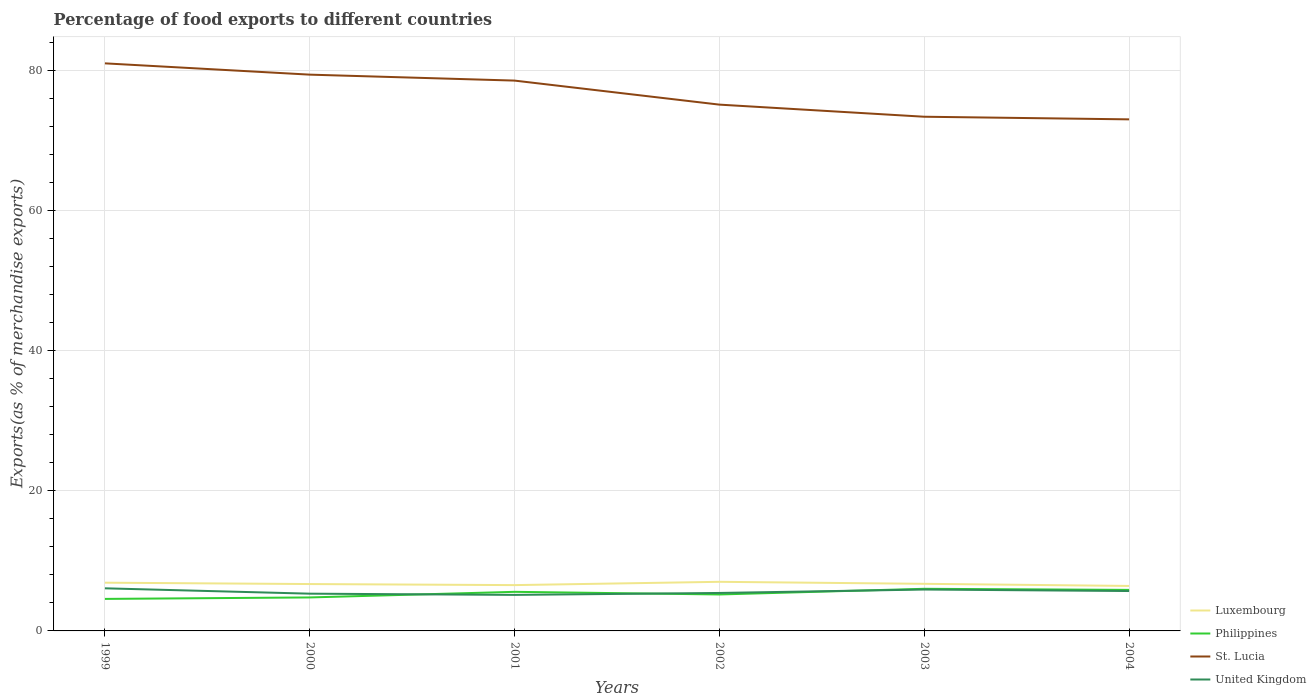How many different coloured lines are there?
Provide a short and direct response. 4. Is the number of lines equal to the number of legend labels?
Provide a succinct answer. Yes. Across all years, what is the maximum percentage of exports to different countries in Luxembourg?
Provide a short and direct response. 6.42. In which year was the percentage of exports to different countries in Luxembourg maximum?
Make the answer very short. 2004. What is the total percentage of exports to different countries in United Kingdom in the graph?
Offer a terse response. -0.38. What is the difference between the highest and the second highest percentage of exports to different countries in United Kingdom?
Offer a terse response. 0.94. What is the difference between the highest and the lowest percentage of exports to different countries in United Kingdom?
Provide a succinct answer. 3. Is the percentage of exports to different countries in United Kingdom strictly greater than the percentage of exports to different countries in Philippines over the years?
Your answer should be very brief. No. How many years are there in the graph?
Offer a very short reply. 6. Does the graph contain any zero values?
Provide a short and direct response. No. What is the title of the graph?
Offer a terse response. Percentage of food exports to different countries. Does "Cyprus" appear as one of the legend labels in the graph?
Make the answer very short. No. What is the label or title of the Y-axis?
Your answer should be very brief. Exports(as % of merchandise exports). What is the Exports(as % of merchandise exports) in Luxembourg in 1999?
Make the answer very short. 6.88. What is the Exports(as % of merchandise exports) of Philippines in 1999?
Offer a terse response. 4.57. What is the Exports(as % of merchandise exports) in St. Lucia in 1999?
Make the answer very short. 81.01. What is the Exports(as % of merchandise exports) of United Kingdom in 1999?
Ensure brevity in your answer.  6.08. What is the Exports(as % of merchandise exports) of Luxembourg in 2000?
Your answer should be compact. 6.69. What is the Exports(as % of merchandise exports) in Philippines in 2000?
Offer a very short reply. 4.78. What is the Exports(as % of merchandise exports) of St. Lucia in 2000?
Make the answer very short. 79.4. What is the Exports(as % of merchandise exports) of United Kingdom in 2000?
Keep it short and to the point. 5.32. What is the Exports(as % of merchandise exports) of Luxembourg in 2001?
Offer a terse response. 6.54. What is the Exports(as % of merchandise exports) of Philippines in 2001?
Your response must be concise. 5.58. What is the Exports(as % of merchandise exports) in St. Lucia in 2001?
Provide a succinct answer. 78.55. What is the Exports(as % of merchandise exports) in United Kingdom in 2001?
Make the answer very short. 5.14. What is the Exports(as % of merchandise exports) in Luxembourg in 2002?
Make the answer very short. 7.01. What is the Exports(as % of merchandise exports) in Philippines in 2002?
Offer a terse response. 5.2. What is the Exports(as % of merchandise exports) in St. Lucia in 2002?
Keep it short and to the point. 75.12. What is the Exports(as % of merchandise exports) in United Kingdom in 2002?
Offer a terse response. 5.42. What is the Exports(as % of merchandise exports) of Luxembourg in 2003?
Your response must be concise. 6.72. What is the Exports(as % of merchandise exports) in Philippines in 2003?
Your answer should be compact. 6.01. What is the Exports(as % of merchandise exports) of St. Lucia in 2003?
Ensure brevity in your answer.  73.39. What is the Exports(as % of merchandise exports) in United Kingdom in 2003?
Make the answer very short. 5.91. What is the Exports(as % of merchandise exports) in Luxembourg in 2004?
Give a very brief answer. 6.42. What is the Exports(as % of merchandise exports) in Philippines in 2004?
Your answer should be compact. 5.86. What is the Exports(as % of merchandise exports) of St. Lucia in 2004?
Provide a succinct answer. 73.02. What is the Exports(as % of merchandise exports) of United Kingdom in 2004?
Offer a very short reply. 5.69. Across all years, what is the maximum Exports(as % of merchandise exports) of Luxembourg?
Provide a short and direct response. 7.01. Across all years, what is the maximum Exports(as % of merchandise exports) in Philippines?
Provide a succinct answer. 6.01. Across all years, what is the maximum Exports(as % of merchandise exports) of St. Lucia?
Offer a very short reply. 81.01. Across all years, what is the maximum Exports(as % of merchandise exports) of United Kingdom?
Ensure brevity in your answer.  6.08. Across all years, what is the minimum Exports(as % of merchandise exports) of Luxembourg?
Make the answer very short. 6.42. Across all years, what is the minimum Exports(as % of merchandise exports) of Philippines?
Offer a very short reply. 4.57. Across all years, what is the minimum Exports(as % of merchandise exports) in St. Lucia?
Provide a short and direct response. 73.02. Across all years, what is the minimum Exports(as % of merchandise exports) of United Kingdom?
Your answer should be compact. 5.14. What is the total Exports(as % of merchandise exports) in Luxembourg in the graph?
Provide a short and direct response. 40.27. What is the total Exports(as % of merchandise exports) of Philippines in the graph?
Your answer should be very brief. 32. What is the total Exports(as % of merchandise exports) of St. Lucia in the graph?
Provide a short and direct response. 460.49. What is the total Exports(as % of merchandise exports) in United Kingdom in the graph?
Your answer should be very brief. 33.56. What is the difference between the Exports(as % of merchandise exports) of Luxembourg in 1999 and that in 2000?
Your answer should be compact. 0.2. What is the difference between the Exports(as % of merchandise exports) in Philippines in 1999 and that in 2000?
Your response must be concise. -0.21. What is the difference between the Exports(as % of merchandise exports) of St. Lucia in 1999 and that in 2000?
Make the answer very short. 1.61. What is the difference between the Exports(as % of merchandise exports) in United Kingdom in 1999 and that in 2000?
Provide a succinct answer. 0.77. What is the difference between the Exports(as % of merchandise exports) in Luxembourg in 1999 and that in 2001?
Offer a terse response. 0.35. What is the difference between the Exports(as % of merchandise exports) in Philippines in 1999 and that in 2001?
Provide a succinct answer. -1.01. What is the difference between the Exports(as % of merchandise exports) of St. Lucia in 1999 and that in 2001?
Your response must be concise. 2.46. What is the difference between the Exports(as % of merchandise exports) of United Kingdom in 1999 and that in 2001?
Offer a terse response. 0.94. What is the difference between the Exports(as % of merchandise exports) of Luxembourg in 1999 and that in 2002?
Your answer should be very brief. -0.12. What is the difference between the Exports(as % of merchandise exports) in Philippines in 1999 and that in 2002?
Provide a succinct answer. -0.63. What is the difference between the Exports(as % of merchandise exports) of St. Lucia in 1999 and that in 2002?
Offer a terse response. 5.89. What is the difference between the Exports(as % of merchandise exports) of United Kingdom in 1999 and that in 2002?
Provide a short and direct response. 0.66. What is the difference between the Exports(as % of merchandise exports) in Luxembourg in 1999 and that in 2003?
Offer a very short reply. 0.16. What is the difference between the Exports(as % of merchandise exports) of Philippines in 1999 and that in 2003?
Your answer should be very brief. -1.44. What is the difference between the Exports(as % of merchandise exports) in St. Lucia in 1999 and that in 2003?
Keep it short and to the point. 7.62. What is the difference between the Exports(as % of merchandise exports) in United Kingdom in 1999 and that in 2003?
Give a very brief answer. 0.17. What is the difference between the Exports(as % of merchandise exports) in Luxembourg in 1999 and that in 2004?
Your answer should be compact. 0.46. What is the difference between the Exports(as % of merchandise exports) of Philippines in 1999 and that in 2004?
Ensure brevity in your answer.  -1.29. What is the difference between the Exports(as % of merchandise exports) of St. Lucia in 1999 and that in 2004?
Your answer should be compact. 7.99. What is the difference between the Exports(as % of merchandise exports) in United Kingdom in 1999 and that in 2004?
Offer a terse response. 0.39. What is the difference between the Exports(as % of merchandise exports) of Luxembourg in 2000 and that in 2001?
Your answer should be compact. 0.15. What is the difference between the Exports(as % of merchandise exports) in Philippines in 2000 and that in 2001?
Give a very brief answer. -0.8. What is the difference between the Exports(as % of merchandise exports) of St. Lucia in 2000 and that in 2001?
Offer a terse response. 0.85. What is the difference between the Exports(as % of merchandise exports) of United Kingdom in 2000 and that in 2001?
Provide a succinct answer. 0.17. What is the difference between the Exports(as % of merchandise exports) of Luxembourg in 2000 and that in 2002?
Offer a very short reply. -0.32. What is the difference between the Exports(as % of merchandise exports) in Philippines in 2000 and that in 2002?
Keep it short and to the point. -0.42. What is the difference between the Exports(as % of merchandise exports) of St. Lucia in 2000 and that in 2002?
Keep it short and to the point. 4.28. What is the difference between the Exports(as % of merchandise exports) in United Kingdom in 2000 and that in 2002?
Provide a succinct answer. -0.1. What is the difference between the Exports(as % of merchandise exports) in Luxembourg in 2000 and that in 2003?
Make the answer very short. -0.04. What is the difference between the Exports(as % of merchandise exports) in Philippines in 2000 and that in 2003?
Your answer should be very brief. -1.23. What is the difference between the Exports(as % of merchandise exports) of St. Lucia in 2000 and that in 2003?
Your answer should be very brief. 6.01. What is the difference between the Exports(as % of merchandise exports) of United Kingdom in 2000 and that in 2003?
Provide a short and direct response. -0.59. What is the difference between the Exports(as % of merchandise exports) in Luxembourg in 2000 and that in 2004?
Give a very brief answer. 0.27. What is the difference between the Exports(as % of merchandise exports) in Philippines in 2000 and that in 2004?
Give a very brief answer. -1.08. What is the difference between the Exports(as % of merchandise exports) in St. Lucia in 2000 and that in 2004?
Ensure brevity in your answer.  6.38. What is the difference between the Exports(as % of merchandise exports) of United Kingdom in 2000 and that in 2004?
Provide a succinct answer. -0.38. What is the difference between the Exports(as % of merchandise exports) of Luxembourg in 2001 and that in 2002?
Provide a short and direct response. -0.47. What is the difference between the Exports(as % of merchandise exports) in Philippines in 2001 and that in 2002?
Offer a very short reply. 0.38. What is the difference between the Exports(as % of merchandise exports) of St. Lucia in 2001 and that in 2002?
Ensure brevity in your answer.  3.43. What is the difference between the Exports(as % of merchandise exports) in United Kingdom in 2001 and that in 2002?
Provide a short and direct response. -0.28. What is the difference between the Exports(as % of merchandise exports) of Luxembourg in 2001 and that in 2003?
Offer a very short reply. -0.19. What is the difference between the Exports(as % of merchandise exports) of Philippines in 2001 and that in 2003?
Your response must be concise. -0.43. What is the difference between the Exports(as % of merchandise exports) of St. Lucia in 2001 and that in 2003?
Offer a very short reply. 5.16. What is the difference between the Exports(as % of merchandise exports) in United Kingdom in 2001 and that in 2003?
Your response must be concise. -0.77. What is the difference between the Exports(as % of merchandise exports) of Luxembourg in 2001 and that in 2004?
Give a very brief answer. 0.12. What is the difference between the Exports(as % of merchandise exports) in Philippines in 2001 and that in 2004?
Your response must be concise. -0.28. What is the difference between the Exports(as % of merchandise exports) in St. Lucia in 2001 and that in 2004?
Offer a terse response. 5.53. What is the difference between the Exports(as % of merchandise exports) in United Kingdom in 2001 and that in 2004?
Your answer should be compact. -0.55. What is the difference between the Exports(as % of merchandise exports) of Luxembourg in 2002 and that in 2003?
Your answer should be very brief. 0.28. What is the difference between the Exports(as % of merchandise exports) of Philippines in 2002 and that in 2003?
Make the answer very short. -0.81. What is the difference between the Exports(as % of merchandise exports) of St. Lucia in 2002 and that in 2003?
Keep it short and to the point. 1.73. What is the difference between the Exports(as % of merchandise exports) of United Kingdom in 2002 and that in 2003?
Give a very brief answer. -0.49. What is the difference between the Exports(as % of merchandise exports) in Luxembourg in 2002 and that in 2004?
Give a very brief answer. 0.59. What is the difference between the Exports(as % of merchandise exports) in Philippines in 2002 and that in 2004?
Give a very brief answer. -0.65. What is the difference between the Exports(as % of merchandise exports) of St. Lucia in 2002 and that in 2004?
Offer a very short reply. 2.1. What is the difference between the Exports(as % of merchandise exports) in United Kingdom in 2002 and that in 2004?
Offer a terse response. -0.27. What is the difference between the Exports(as % of merchandise exports) in Luxembourg in 2003 and that in 2004?
Ensure brevity in your answer.  0.3. What is the difference between the Exports(as % of merchandise exports) in Philippines in 2003 and that in 2004?
Your answer should be compact. 0.16. What is the difference between the Exports(as % of merchandise exports) of St. Lucia in 2003 and that in 2004?
Provide a short and direct response. 0.37. What is the difference between the Exports(as % of merchandise exports) of United Kingdom in 2003 and that in 2004?
Make the answer very short. 0.21. What is the difference between the Exports(as % of merchandise exports) of Luxembourg in 1999 and the Exports(as % of merchandise exports) of Philippines in 2000?
Provide a succinct answer. 2.11. What is the difference between the Exports(as % of merchandise exports) in Luxembourg in 1999 and the Exports(as % of merchandise exports) in St. Lucia in 2000?
Provide a succinct answer. -72.51. What is the difference between the Exports(as % of merchandise exports) of Luxembourg in 1999 and the Exports(as % of merchandise exports) of United Kingdom in 2000?
Give a very brief answer. 1.57. What is the difference between the Exports(as % of merchandise exports) in Philippines in 1999 and the Exports(as % of merchandise exports) in St. Lucia in 2000?
Provide a succinct answer. -74.83. What is the difference between the Exports(as % of merchandise exports) of Philippines in 1999 and the Exports(as % of merchandise exports) of United Kingdom in 2000?
Your answer should be very brief. -0.75. What is the difference between the Exports(as % of merchandise exports) in St. Lucia in 1999 and the Exports(as % of merchandise exports) in United Kingdom in 2000?
Keep it short and to the point. 75.69. What is the difference between the Exports(as % of merchandise exports) of Luxembourg in 1999 and the Exports(as % of merchandise exports) of Philippines in 2001?
Your response must be concise. 1.31. What is the difference between the Exports(as % of merchandise exports) in Luxembourg in 1999 and the Exports(as % of merchandise exports) in St. Lucia in 2001?
Your answer should be very brief. -71.67. What is the difference between the Exports(as % of merchandise exports) in Luxembourg in 1999 and the Exports(as % of merchandise exports) in United Kingdom in 2001?
Provide a succinct answer. 1.74. What is the difference between the Exports(as % of merchandise exports) in Philippines in 1999 and the Exports(as % of merchandise exports) in St. Lucia in 2001?
Keep it short and to the point. -73.98. What is the difference between the Exports(as % of merchandise exports) in Philippines in 1999 and the Exports(as % of merchandise exports) in United Kingdom in 2001?
Your answer should be compact. -0.57. What is the difference between the Exports(as % of merchandise exports) in St. Lucia in 1999 and the Exports(as % of merchandise exports) in United Kingdom in 2001?
Provide a short and direct response. 75.87. What is the difference between the Exports(as % of merchandise exports) of Luxembourg in 1999 and the Exports(as % of merchandise exports) of Philippines in 2002?
Offer a terse response. 1.68. What is the difference between the Exports(as % of merchandise exports) of Luxembourg in 1999 and the Exports(as % of merchandise exports) of St. Lucia in 2002?
Offer a terse response. -68.24. What is the difference between the Exports(as % of merchandise exports) in Luxembourg in 1999 and the Exports(as % of merchandise exports) in United Kingdom in 2002?
Your answer should be compact. 1.47. What is the difference between the Exports(as % of merchandise exports) of Philippines in 1999 and the Exports(as % of merchandise exports) of St. Lucia in 2002?
Your answer should be compact. -70.55. What is the difference between the Exports(as % of merchandise exports) of Philippines in 1999 and the Exports(as % of merchandise exports) of United Kingdom in 2002?
Your answer should be very brief. -0.85. What is the difference between the Exports(as % of merchandise exports) in St. Lucia in 1999 and the Exports(as % of merchandise exports) in United Kingdom in 2002?
Provide a short and direct response. 75.59. What is the difference between the Exports(as % of merchandise exports) of Luxembourg in 1999 and the Exports(as % of merchandise exports) of Philippines in 2003?
Keep it short and to the point. 0.87. What is the difference between the Exports(as % of merchandise exports) of Luxembourg in 1999 and the Exports(as % of merchandise exports) of St. Lucia in 2003?
Your answer should be compact. -66.51. What is the difference between the Exports(as % of merchandise exports) in Luxembourg in 1999 and the Exports(as % of merchandise exports) in United Kingdom in 2003?
Your answer should be very brief. 0.98. What is the difference between the Exports(as % of merchandise exports) in Philippines in 1999 and the Exports(as % of merchandise exports) in St. Lucia in 2003?
Provide a short and direct response. -68.82. What is the difference between the Exports(as % of merchandise exports) of Philippines in 1999 and the Exports(as % of merchandise exports) of United Kingdom in 2003?
Give a very brief answer. -1.34. What is the difference between the Exports(as % of merchandise exports) in St. Lucia in 1999 and the Exports(as % of merchandise exports) in United Kingdom in 2003?
Make the answer very short. 75.1. What is the difference between the Exports(as % of merchandise exports) of Luxembourg in 1999 and the Exports(as % of merchandise exports) of Philippines in 2004?
Make the answer very short. 1.03. What is the difference between the Exports(as % of merchandise exports) in Luxembourg in 1999 and the Exports(as % of merchandise exports) in St. Lucia in 2004?
Your response must be concise. -66.13. What is the difference between the Exports(as % of merchandise exports) in Luxembourg in 1999 and the Exports(as % of merchandise exports) in United Kingdom in 2004?
Your response must be concise. 1.19. What is the difference between the Exports(as % of merchandise exports) in Philippines in 1999 and the Exports(as % of merchandise exports) in St. Lucia in 2004?
Give a very brief answer. -68.45. What is the difference between the Exports(as % of merchandise exports) in Philippines in 1999 and the Exports(as % of merchandise exports) in United Kingdom in 2004?
Keep it short and to the point. -1.12. What is the difference between the Exports(as % of merchandise exports) in St. Lucia in 1999 and the Exports(as % of merchandise exports) in United Kingdom in 2004?
Your answer should be very brief. 75.32. What is the difference between the Exports(as % of merchandise exports) of Luxembourg in 2000 and the Exports(as % of merchandise exports) of Philippines in 2001?
Give a very brief answer. 1.11. What is the difference between the Exports(as % of merchandise exports) of Luxembourg in 2000 and the Exports(as % of merchandise exports) of St. Lucia in 2001?
Give a very brief answer. -71.86. What is the difference between the Exports(as % of merchandise exports) of Luxembourg in 2000 and the Exports(as % of merchandise exports) of United Kingdom in 2001?
Your answer should be very brief. 1.55. What is the difference between the Exports(as % of merchandise exports) of Philippines in 2000 and the Exports(as % of merchandise exports) of St. Lucia in 2001?
Your answer should be compact. -73.77. What is the difference between the Exports(as % of merchandise exports) of Philippines in 2000 and the Exports(as % of merchandise exports) of United Kingdom in 2001?
Offer a terse response. -0.36. What is the difference between the Exports(as % of merchandise exports) of St. Lucia in 2000 and the Exports(as % of merchandise exports) of United Kingdom in 2001?
Your answer should be very brief. 74.26. What is the difference between the Exports(as % of merchandise exports) in Luxembourg in 2000 and the Exports(as % of merchandise exports) in Philippines in 2002?
Give a very brief answer. 1.49. What is the difference between the Exports(as % of merchandise exports) in Luxembourg in 2000 and the Exports(as % of merchandise exports) in St. Lucia in 2002?
Keep it short and to the point. -68.43. What is the difference between the Exports(as % of merchandise exports) of Luxembourg in 2000 and the Exports(as % of merchandise exports) of United Kingdom in 2002?
Give a very brief answer. 1.27. What is the difference between the Exports(as % of merchandise exports) in Philippines in 2000 and the Exports(as % of merchandise exports) in St. Lucia in 2002?
Ensure brevity in your answer.  -70.34. What is the difference between the Exports(as % of merchandise exports) of Philippines in 2000 and the Exports(as % of merchandise exports) of United Kingdom in 2002?
Your answer should be very brief. -0.64. What is the difference between the Exports(as % of merchandise exports) in St. Lucia in 2000 and the Exports(as % of merchandise exports) in United Kingdom in 2002?
Your answer should be very brief. 73.98. What is the difference between the Exports(as % of merchandise exports) in Luxembourg in 2000 and the Exports(as % of merchandise exports) in Philippines in 2003?
Your answer should be very brief. 0.68. What is the difference between the Exports(as % of merchandise exports) of Luxembourg in 2000 and the Exports(as % of merchandise exports) of St. Lucia in 2003?
Provide a short and direct response. -66.7. What is the difference between the Exports(as % of merchandise exports) of Luxembourg in 2000 and the Exports(as % of merchandise exports) of United Kingdom in 2003?
Ensure brevity in your answer.  0.78. What is the difference between the Exports(as % of merchandise exports) in Philippines in 2000 and the Exports(as % of merchandise exports) in St. Lucia in 2003?
Your answer should be compact. -68.61. What is the difference between the Exports(as % of merchandise exports) of Philippines in 2000 and the Exports(as % of merchandise exports) of United Kingdom in 2003?
Your response must be concise. -1.13. What is the difference between the Exports(as % of merchandise exports) in St. Lucia in 2000 and the Exports(as % of merchandise exports) in United Kingdom in 2003?
Your response must be concise. 73.49. What is the difference between the Exports(as % of merchandise exports) in Luxembourg in 2000 and the Exports(as % of merchandise exports) in Philippines in 2004?
Offer a terse response. 0.83. What is the difference between the Exports(as % of merchandise exports) of Luxembourg in 2000 and the Exports(as % of merchandise exports) of St. Lucia in 2004?
Ensure brevity in your answer.  -66.33. What is the difference between the Exports(as % of merchandise exports) of Philippines in 2000 and the Exports(as % of merchandise exports) of St. Lucia in 2004?
Your answer should be compact. -68.24. What is the difference between the Exports(as % of merchandise exports) of Philippines in 2000 and the Exports(as % of merchandise exports) of United Kingdom in 2004?
Your answer should be compact. -0.91. What is the difference between the Exports(as % of merchandise exports) of St. Lucia in 2000 and the Exports(as % of merchandise exports) of United Kingdom in 2004?
Keep it short and to the point. 73.71. What is the difference between the Exports(as % of merchandise exports) in Luxembourg in 2001 and the Exports(as % of merchandise exports) in Philippines in 2002?
Your response must be concise. 1.34. What is the difference between the Exports(as % of merchandise exports) of Luxembourg in 2001 and the Exports(as % of merchandise exports) of St. Lucia in 2002?
Your answer should be compact. -68.58. What is the difference between the Exports(as % of merchandise exports) of Luxembourg in 2001 and the Exports(as % of merchandise exports) of United Kingdom in 2002?
Offer a terse response. 1.12. What is the difference between the Exports(as % of merchandise exports) in Philippines in 2001 and the Exports(as % of merchandise exports) in St. Lucia in 2002?
Your answer should be very brief. -69.54. What is the difference between the Exports(as % of merchandise exports) of Philippines in 2001 and the Exports(as % of merchandise exports) of United Kingdom in 2002?
Make the answer very short. 0.16. What is the difference between the Exports(as % of merchandise exports) of St. Lucia in 2001 and the Exports(as % of merchandise exports) of United Kingdom in 2002?
Provide a short and direct response. 73.13. What is the difference between the Exports(as % of merchandise exports) of Luxembourg in 2001 and the Exports(as % of merchandise exports) of Philippines in 2003?
Your response must be concise. 0.53. What is the difference between the Exports(as % of merchandise exports) of Luxembourg in 2001 and the Exports(as % of merchandise exports) of St. Lucia in 2003?
Ensure brevity in your answer.  -66.85. What is the difference between the Exports(as % of merchandise exports) of Luxembourg in 2001 and the Exports(as % of merchandise exports) of United Kingdom in 2003?
Provide a short and direct response. 0.63. What is the difference between the Exports(as % of merchandise exports) in Philippines in 2001 and the Exports(as % of merchandise exports) in St. Lucia in 2003?
Provide a succinct answer. -67.81. What is the difference between the Exports(as % of merchandise exports) of Philippines in 2001 and the Exports(as % of merchandise exports) of United Kingdom in 2003?
Your answer should be compact. -0.33. What is the difference between the Exports(as % of merchandise exports) of St. Lucia in 2001 and the Exports(as % of merchandise exports) of United Kingdom in 2003?
Your answer should be very brief. 72.64. What is the difference between the Exports(as % of merchandise exports) of Luxembourg in 2001 and the Exports(as % of merchandise exports) of Philippines in 2004?
Keep it short and to the point. 0.68. What is the difference between the Exports(as % of merchandise exports) of Luxembourg in 2001 and the Exports(as % of merchandise exports) of St. Lucia in 2004?
Your response must be concise. -66.48. What is the difference between the Exports(as % of merchandise exports) in Luxembourg in 2001 and the Exports(as % of merchandise exports) in United Kingdom in 2004?
Ensure brevity in your answer.  0.85. What is the difference between the Exports(as % of merchandise exports) of Philippines in 2001 and the Exports(as % of merchandise exports) of St. Lucia in 2004?
Ensure brevity in your answer.  -67.44. What is the difference between the Exports(as % of merchandise exports) in Philippines in 2001 and the Exports(as % of merchandise exports) in United Kingdom in 2004?
Provide a short and direct response. -0.11. What is the difference between the Exports(as % of merchandise exports) of St. Lucia in 2001 and the Exports(as % of merchandise exports) of United Kingdom in 2004?
Offer a very short reply. 72.86. What is the difference between the Exports(as % of merchandise exports) in Luxembourg in 2002 and the Exports(as % of merchandise exports) in St. Lucia in 2003?
Your response must be concise. -66.38. What is the difference between the Exports(as % of merchandise exports) of Luxembourg in 2002 and the Exports(as % of merchandise exports) of United Kingdom in 2003?
Your answer should be compact. 1.1. What is the difference between the Exports(as % of merchandise exports) in Philippines in 2002 and the Exports(as % of merchandise exports) in St. Lucia in 2003?
Your answer should be very brief. -68.19. What is the difference between the Exports(as % of merchandise exports) of Philippines in 2002 and the Exports(as % of merchandise exports) of United Kingdom in 2003?
Provide a succinct answer. -0.7. What is the difference between the Exports(as % of merchandise exports) in St. Lucia in 2002 and the Exports(as % of merchandise exports) in United Kingdom in 2003?
Make the answer very short. 69.21. What is the difference between the Exports(as % of merchandise exports) in Luxembourg in 2002 and the Exports(as % of merchandise exports) in Philippines in 2004?
Your response must be concise. 1.15. What is the difference between the Exports(as % of merchandise exports) in Luxembourg in 2002 and the Exports(as % of merchandise exports) in St. Lucia in 2004?
Provide a short and direct response. -66.01. What is the difference between the Exports(as % of merchandise exports) of Luxembourg in 2002 and the Exports(as % of merchandise exports) of United Kingdom in 2004?
Give a very brief answer. 1.32. What is the difference between the Exports(as % of merchandise exports) of Philippines in 2002 and the Exports(as % of merchandise exports) of St. Lucia in 2004?
Make the answer very short. -67.81. What is the difference between the Exports(as % of merchandise exports) in Philippines in 2002 and the Exports(as % of merchandise exports) in United Kingdom in 2004?
Provide a short and direct response. -0.49. What is the difference between the Exports(as % of merchandise exports) of St. Lucia in 2002 and the Exports(as % of merchandise exports) of United Kingdom in 2004?
Keep it short and to the point. 69.43. What is the difference between the Exports(as % of merchandise exports) in Luxembourg in 2003 and the Exports(as % of merchandise exports) in Philippines in 2004?
Make the answer very short. 0.87. What is the difference between the Exports(as % of merchandise exports) of Luxembourg in 2003 and the Exports(as % of merchandise exports) of St. Lucia in 2004?
Make the answer very short. -66.29. What is the difference between the Exports(as % of merchandise exports) of Luxembourg in 2003 and the Exports(as % of merchandise exports) of United Kingdom in 2004?
Offer a very short reply. 1.03. What is the difference between the Exports(as % of merchandise exports) of Philippines in 2003 and the Exports(as % of merchandise exports) of St. Lucia in 2004?
Provide a short and direct response. -67. What is the difference between the Exports(as % of merchandise exports) of Philippines in 2003 and the Exports(as % of merchandise exports) of United Kingdom in 2004?
Make the answer very short. 0.32. What is the difference between the Exports(as % of merchandise exports) of St. Lucia in 2003 and the Exports(as % of merchandise exports) of United Kingdom in 2004?
Offer a very short reply. 67.7. What is the average Exports(as % of merchandise exports) in Luxembourg per year?
Your answer should be very brief. 6.71. What is the average Exports(as % of merchandise exports) of Philippines per year?
Provide a succinct answer. 5.33. What is the average Exports(as % of merchandise exports) of St. Lucia per year?
Provide a succinct answer. 76.75. What is the average Exports(as % of merchandise exports) of United Kingdom per year?
Make the answer very short. 5.59. In the year 1999, what is the difference between the Exports(as % of merchandise exports) in Luxembourg and Exports(as % of merchandise exports) in Philippines?
Provide a succinct answer. 2.31. In the year 1999, what is the difference between the Exports(as % of merchandise exports) in Luxembourg and Exports(as % of merchandise exports) in St. Lucia?
Ensure brevity in your answer.  -74.13. In the year 1999, what is the difference between the Exports(as % of merchandise exports) of Luxembourg and Exports(as % of merchandise exports) of United Kingdom?
Your answer should be very brief. 0.8. In the year 1999, what is the difference between the Exports(as % of merchandise exports) in Philippines and Exports(as % of merchandise exports) in St. Lucia?
Your answer should be compact. -76.44. In the year 1999, what is the difference between the Exports(as % of merchandise exports) in Philippines and Exports(as % of merchandise exports) in United Kingdom?
Offer a terse response. -1.51. In the year 1999, what is the difference between the Exports(as % of merchandise exports) of St. Lucia and Exports(as % of merchandise exports) of United Kingdom?
Your answer should be compact. 74.93. In the year 2000, what is the difference between the Exports(as % of merchandise exports) of Luxembourg and Exports(as % of merchandise exports) of Philippines?
Give a very brief answer. 1.91. In the year 2000, what is the difference between the Exports(as % of merchandise exports) of Luxembourg and Exports(as % of merchandise exports) of St. Lucia?
Make the answer very short. -72.71. In the year 2000, what is the difference between the Exports(as % of merchandise exports) in Luxembourg and Exports(as % of merchandise exports) in United Kingdom?
Offer a very short reply. 1.37. In the year 2000, what is the difference between the Exports(as % of merchandise exports) of Philippines and Exports(as % of merchandise exports) of St. Lucia?
Keep it short and to the point. -74.62. In the year 2000, what is the difference between the Exports(as % of merchandise exports) in Philippines and Exports(as % of merchandise exports) in United Kingdom?
Your response must be concise. -0.54. In the year 2000, what is the difference between the Exports(as % of merchandise exports) in St. Lucia and Exports(as % of merchandise exports) in United Kingdom?
Give a very brief answer. 74.08. In the year 2001, what is the difference between the Exports(as % of merchandise exports) of Luxembourg and Exports(as % of merchandise exports) of Philippines?
Give a very brief answer. 0.96. In the year 2001, what is the difference between the Exports(as % of merchandise exports) in Luxembourg and Exports(as % of merchandise exports) in St. Lucia?
Offer a very short reply. -72.01. In the year 2001, what is the difference between the Exports(as % of merchandise exports) in Luxembourg and Exports(as % of merchandise exports) in United Kingdom?
Offer a terse response. 1.4. In the year 2001, what is the difference between the Exports(as % of merchandise exports) in Philippines and Exports(as % of merchandise exports) in St. Lucia?
Offer a terse response. -72.97. In the year 2001, what is the difference between the Exports(as % of merchandise exports) in Philippines and Exports(as % of merchandise exports) in United Kingdom?
Make the answer very short. 0.44. In the year 2001, what is the difference between the Exports(as % of merchandise exports) of St. Lucia and Exports(as % of merchandise exports) of United Kingdom?
Your response must be concise. 73.41. In the year 2002, what is the difference between the Exports(as % of merchandise exports) in Luxembourg and Exports(as % of merchandise exports) in Philippines?
Give a very brief answer. 1.81. In the year 2002, what is the difference between the Exports(as % of merchandise exports) of Luxembourg and Exports(as % of merchandise exports) of St. Lucia?
Offer a very short reply. -68.11. In the year 2002, what is the difference between the Exports(as % of merchandise exports) of Luxembourg and Exports(as % of merchandise exports) of United Kingdom?
Your response must be concise. 1.59. In the year 2002, what is the difference between the Exports(as % of merchandise exports) of Philippines and Exports(as % of merchandise exports) of St. Lucia?
Offer a very short reply. -69.92. In the year 2002, what is the difference between the Exports(as % of merchandise exports) of Philippines and Exports(as % of merchandise exports) of United Kingdom?
Your answer should be very brief. -0.21. In the year 2002, what is the difference between the Exports(as % of merchandise exports) of St. Lucia and Exports(as % of merchandise exports) of United Kingdom?
Offer a very short reply. 69.7. In the year 2003, what is the difference between the Exports(as % of merchandise exports) of Luxembourg and Exports(as % of merchandise exports) of Philippines?
Give a very brief answer. 0.71. In the year 2003, what is the difference between the Exports(as % of merchandise exports) of Luxembourg and Exports(as % of merchandise exports) of St. Lucia?
Your response must be concise. -66.67. In the year 2003, what is the difference between the Exports(as % of merchandise exports) in Luxembourg and Exports(as % of merchandise exports) in United Kingdom?
Keep it short and to the point. 0.82. In the year 2003, what is the difference between the Exports(as % of merchandise exports) of Philippines and Exports(as % of merchandise exports) of St. Lucia?
Your response must be concise. -67.38. In the year 2003, what is the difference between the Exports(as % of merchandise exports) of Philippines and Exports(as % of merchandise exports) of United Kingdom?
Ensure brevity in your answer.  0.1. In the year 2003, what is the difference between the Exports(as % of merchandise exports) of St. Lucia and Exports(as % of merchandise exports) of United Kingdom?
Provide a short and direct response. 67.48. In the year 2004, what is the difference between the Exports(as % of merchandise exports) in Luxembourg and Exports(as % of merchandise exports) in Philippines?
Your answer should be compact. 0.56. In the year 2004, what is the difference between the Exports(as % of merchandise exports) of Luxembourg and Exports(as % of merchandise exports) of St. Lucia?
Provide a short and direct response. -66.6. In the year 2004, what is the difference between the Exports(as % of merchandise exports) in Luxembourg and Exports(as % of merchandise exports) in United Kingdom?
Your answer should be very brief. 0.73. In the year 2004, what is the difference between the Exports(as % of merchandise exports) of Philippines and Exports(as % of merchandise exports) of St. Lucia?
Ensure brevity in your answer.  -67.16. In the year 2004, what is the difference between the Exports(as % of merchandise exports) in Philippines and Exports(as % of merchandise exports) in United Kingdom?
Give a very brief answer. 0.16. In the year 2004, what is the difference between the Exports(as % of merchandise exports) in St. Lucia and Exports(as % of merchandise exports) in United Kingdom?
Keep it short and to the point. 67.32. What is the ratio of the Exports(as % of merchandise exports) of Luxembourg in 1999 to that in 2000?
Keep it short and to the point. 1.03. What is the ratio of the Exports(as % of merchandise exports) of Philippines in 1999 to that in 2000?
Provide a succinct answer. 0.96. What is the ratio of the Exports(as % of merchandise exports) of St. Lucia in 1999 to that in 2000?
Make the answer very short. 1.02. What is the ratio of the Exports(as % of merchandise exports) of United Kingdom in 1999 to that in 2000?
Your response must be concise. 1.14. What is the ratio of the Exports(as % of merchandise exports) of Luxembourg in 1999 to that in 2001?
Give a very brief answer. 1.05. What is the ratio of the Exports(as % of merchandise exports) in Philippines in 1999 to that in 2001?
Your response must be concise. 0.82. What is the ratio of the Exports(as % of merchandise exports) of St. Lucia in 1999 to that in 2001?
Your response must be concise. 1.03. What is the ratio of the Exports(as % of merchandise exports) of United Kingdom in 1999 to that in 2001?
Provide a succinct answer. 1.18. What is the ratio of the Exports(as % of merchandise exports) in Luxembourg in 1999 to that in 2002?
Provide a short and direct response. 0.98. What is the ratio of the Exports(as % of merchandise exports) in Philippines in 1999 to that in 2002?
Provide a short and direct response. 0.88. What is the ratio of the Exports(as % of merchandise exports) in St. Lucia in 1999 to that in 2002?
Your answer should be compact. 1.08. What is the ratio of the Exports(as % of merchandise exports) of United Kingdom in 1999 to that in 2002?
Your answer should be compact. 1.12. What is the ratio of the Exports(as % of merchandise exports) in Luxembourg in 1999 to that in 2003?
Your answer should be compact. 1.02. What is the ratio of the Exports(as % of merchandise exports) of Philippines in 1999 to that in 2003?
Provide a succinct answer. 0.76. What is the ratio of the Exports(as % of merchandise exports) in St. Lucia in 1999 to that in 2003?
Provide a succinct answer. 1.1. What is the ratio of the Exports(as % of merchandise exports) of United Kingdom in 1999 to that in 2003?
Offer a terse response. 1.03. What is the ratio of the Exports(as % of merchandise exports) of Luxembourg in 1999 to that in 2004?
Provide a short and direct response. 1.07. What is the ratio of the Exports(as % of merchandise exports) of Philippines in 1999 to that in 2004?
Provide a succinct answer. 0.78. What is the ratio of the Exports(as % of merchandise exports) of St. Lucia in 1999 to that in 2004?
Ensure brevity in your answer.  1.11. What is the ratio of the Exports(as % of merchandise exports) of United Kingdom in 1999 to that in 2004?
Offer a very short reply. 1.07. What is the ratio of the Exports(as % of merchandise exports) in Luxembourg in 2000 to that in 2001?
Ensure brevity in your answer.  1.02. What is the ratio of the Exports(as % of merchandise exports) in Philippines in 2000 to that in 2001?
Your answer should be compact. 0.86. What is the ratio of the Exports(as % of merchandise exports) in St. Lucia in 2000 to that in 2001?
Your answer should be compact. 1.01. What is the ratio of the Exports(as % of merchandise exports) of United Kingdom in 2000 to that in 2001?
Your answer should be compact. 1.03. What is the ratio of the Exports(as % of merchandise exports) of Luxembourg in 2000 to that in 2002?
Make the answer very short. 0.95. What is the ratio of the Exports(as % of merchandise exports) of Philippines in 2000 to that in 2002?
Your response must be concise. 0.92. What is the ratio of the Exports(as % of merchandise exports) of St. Lucia in 2000 to that in 2002?
Your response must be concise. 1.06. What is the ratio of the Exports(as % of merchandise exports) of United Kingdom in 2000 to that in 2002?
Your answer should be very brief. 0.98. What is the ratio of the Exports(as % of merchandise exports) of Luxembourg in 2000 to that in 2003?
Make the answer very short. 0.99. What is the ratio of the Exports(as % of merchandise exports) of Philippines in 2000 to that in 2003?
Your response must be concise. 0.79. What is the ratio of the Exports(as % of merchandise exports) in St. Lucia in 2000 to that in 2003?
Provide a short and direct response. 1.08. What is the ratio of the Exports(as % of merchandise exports) in Luxembourg in 2000 to that in 2004?
Provide a short and direct response. 1.04. What is the ratio of the Exports(as % of merchandise exports) of Philippines in 2000 to that in 2004?
Make the answer very short. 0.82. What is the ratio of the Exports(as % of merchandise exports) of St. Lucia in 2000 to that in 2004?
Make the answer very short. 1.09. What is the ratio of the Exports(as % of merchandise exports) in United Kingdom in 2000 to that in 2004?
Your answer should be compact. 0.93. What is the ratio of the Exports(as % of merchandise exports) in Luxembourg in 2001 to that in 2002?
Give a very brief answer. 0.93. What is the ratio of the Exports(as % of merchandise exports) in Philippines in 2001 to that in 2002?
Your answer should be very brief. 1.07. What is the ratio of the Exports(as % of merchandise exports) of St. Lucia in 2001 to that in 2002?
Give a very brief answer. 1.05. What is the ratio of the Exports(as % of merchandise exports) of United Kingdom in 2001 to that in 2002?
Provide a short and direct response. 0.95. What is the ratio of the Exports(as % of merchandise exports) of Luxembourg in 2001 to that in 2003?
Make the answer very short. 0.97. What is the ratio of the Exports(as % of merchandise exports) of Philippines in 2001 to that in 2003?
Provide a succinct answer. 0.93. What is the ratio of the Exports(as % of merchandise exports) of St. Lucia in 2001 to that in 2003?
Your response must be concise. 1.07. What is the ratio of the Exports(as % of merchandise exports) of United Kingdom in 2001 to that in 2003?
Your answer should be very brief. 0.87. What is the ratio of the Exports(as % of merchandise exports) of Luxembourg in 2001 to that in 2004?
Make the answer very short. 1.02. What is the ratio of the Exports(as % of merchandise exports) in Philippines in 2001 to that in 2004?
Give a very brief answer. 0.95. What is the ratio of the Exports(as % of merchandise exports) of St. Lucia in 2001 to that in 2004?
Offer a terse response. 1.08. What is the ratio of the Exports(as % of merchandise exports) of United Kingdom in 2001 to that in 2004?
Ensure brevity in your answer.  0.9. What is the ratio of the Exports(as % of merchandise exports) in Luxembourg in 2002 to that in 2003?
Keep it short and to the point. 1.04. What is the ratio of the Exports(as % of merchandise exports) in Philippines in 2002 to that in 2003?
Your answer should be compact. 0.87. What is the ratio of the Exports(as % of merchandise exports) in St. Lucia in 2002 to that in 2003?
Offer a very short reply. 1.02. What is the ratio of the Exports(as % of merchandise exports) in United Kingdom in 2002 to that in 2003?
Your answer should be very brief. 0.92. What is the ratio of the Exports(as % of merchandise exports) in Luxembourg in 2002 to that in 2004?
Provide a succinct answer. 1.09. What is the ratio of the Exports(as % of merchandise exports) of Philippines in 2002 to that in 2004?
Your response must be concise. 0.89. What is the ratio of the Exports(as % of merchandise exports) of St. Lucia in 2002 to that in 2004?
Make the answer very short. 1.03. What is the ratio of the Exports(as % of merchandise exports) of United Kingdom in 2002 to that in 2004?
Offer a terse response. 0.95. What is the ratio of the Exports(as % of merchandise exports) of Luxembourg in 2003 to that in 2004?
Provide a short and direct response. 1.05. What is the ratio of the Exports(as % of merchandise exports) in Philippines in 2003 to that in 2004?
Keep it short and to the point. 1.03. What is the ratio of the Exports(as % of merchandise exports) in United Kingdom in 2003 to that in 2004?
Your answer should be very brief. 1.04. What is the difference between the highest and the second highest Exports(as % of merchandise exports) in Luxembourg?
Provide a short and direct response. 0.12. What is the difference between the highest and the second highest Exports(as % of merchandise exports) of Philippines?
Ensure brevity in your answer.  0.16. What is the difference between the highest and the second highest Exports(as % of merchandise exports) in St. Lucia?
Your answer should be compact. 1.61. What is the difference between the highest and the second highest Exports(as % of merchandise exports) in United Kingdom?
Make the answer very short. 0.17. What is the difference between the highest and the lowest Exports(as % of merchandise exports) of Luxembourg?
Ensure brevity in your answer.  0.59. What is the difference between the highest and the lowest Exports(as % of merchandise exports) of Philippines?
Your answer should be compact. 1.44. What is the difference between the highest and the lowest Exports(as % of merchandise exports) of St. Lucia?
Keep it short and to the point. 7.99. What is the difference between the highest and the lowest Exports(as % of merchandise exports) of United Kingdom?
Offer a terse response. 0.94. 